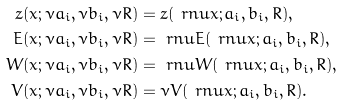Convert formula to latex. <formula><loc_0><loc_0><loc_500><loc_500>z ( x ; \nu a _ { i } , \nu b _ { i } , \nu R ) & = z ( \ r n u x ; a _ { i } , b _ { i } , R ) , \\ E ( x ; \nu a _ { i } , \nu b _ { i } , \nu R ) & = \ r n u E ( \ r n u x ; a _ { i } , b _ { i } , R ) , \\ W ( x ; \nu a _ { i } , \nu b _ { i } , \nu R ) & = \ r n u W ( \ r n u x ; a _ { i } , b _ { i } , R ) , \\ V ( x ; \nu a _ { i } , \nu b _ { i } , \nu R ) & = \nu V ( \ r n u x ; a _ { i } , b _ { i } , R ) .</formula> 